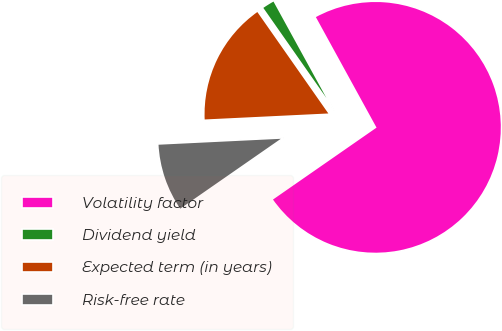Convert chart. <chart><loc_0><loc_0><loc_500><loc_500><pie_chart><fcel>Volatility factor<fcel>Dividend yield<fcel>Expected term (in years)<fcel>Risk-free rate<nl><fcel>73.32%<fcel>1.73%<fcel>16.05%<fcel>8.89%<nl></chart> 